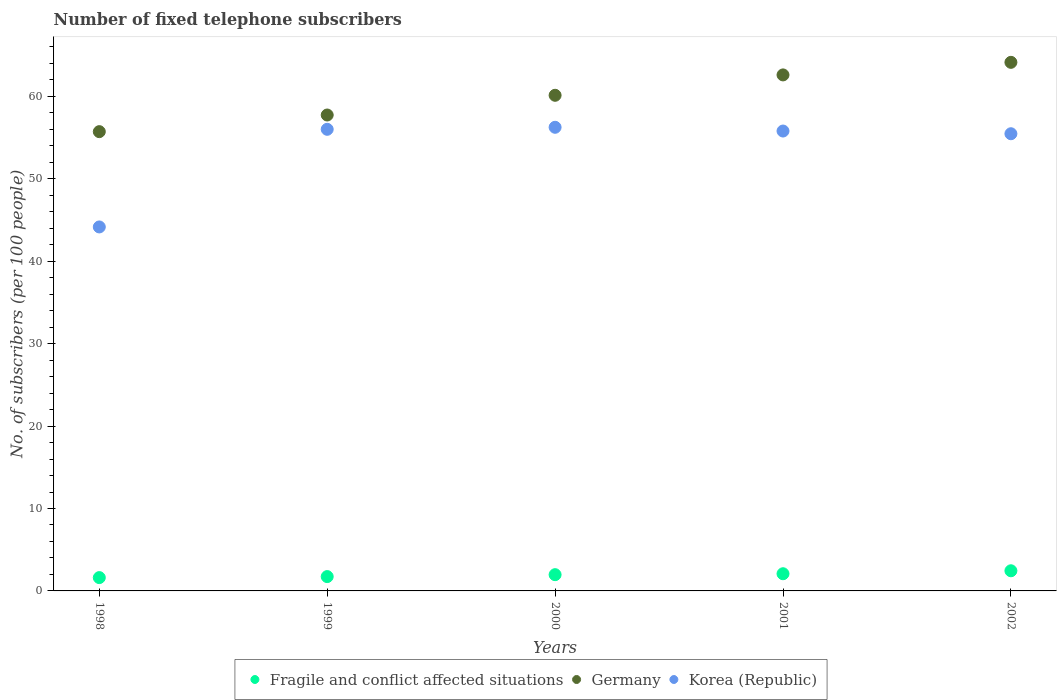How many different coloured dotlines are there?
Make the answer very short. 3. Is the number of dotlines equal to the number of legend labels?
Your answer should be very brief. Yes. What is the number of fixed telephone subscribers in Korea (Republic) in 2001?
Give a very brief answer. 55.8. Across all years, what is the maximum number of fixed telephone subscribers in Germany?
Your answer should be compact. 64.13. Across all years, what is the minimum number of fixed telephone subscribers in Korea (Republic)?
Ensure brevity in your answer.  44.16. What is the total number of fixed telephone subscribers in Fragile and conflict affected situations in the graph?
Your answer should be very brief. 9.86. What is the difference between the number of fixed telephone subscribers in Fragile and conflict affected situations in 2001 and that in 2002?
Keep it short and to the point. -0.36. What is the difference between the number of fixed telephone subscribers in Fragile and conflict affected situations in 1998 and the number of fixed telephone subscribers in Korea (Republic) in 2002?
Ensure brevity in your answer.  -53.85. What is the average number of fixed telephone subscribers in Korea (Republic) per year?
Your answer should be very brief. 53.54. In the year 2001, what is the difference between the number of fixed telephone subscribers in Germany and number of fixed telephone subscribers in Fragile and conflict affected situations?
Provide a succinct answer. 60.52. In how many years, is the number of fixed telephone subscribers in Korea (Republic) greater than 52?
Provide a short and direct response. 4. What is the ratio of the number of fixed telephone subscribers in Germany in 1999 to that in 2000?
Offer a very short reply. 0.96. What is the difference between the highest and the second highest number of fixed telephone subscribers in Fragile and conflict affected situations?
Your response must be concise. 0.36. What is the difference between the highest and the lowest number of fixed telephone subscribers in Fragile and conflict affected situations?
Your answer should be very brief. 0.83. Is the sum of the number of fixed telephone subscribers in Fragile and conflict affected situations in 1999 and 2000 greater than the maximum number of fixed telephone subscribers in Germany across all years?
Ensure brevity in your answer.  No. Does the number of fixed telephone subscribers in Korea (Republic) monotonically increase over the years?
Offer a terse response. No. Is the number of fixed telephone subscribers in Korea (Republic) strictly less than the number of fixed telephone subscribers in Germany over the years?
Give a very brief answer. Yes. What is the difference between two consecutive major ticks on the Y-axis?
Offer a very short reply. 10. Are the values on the major ticks of Y-axis written in scientific E-notation?
Give a very brief answer. No. Does the graph contain grids?
Give a very brief answer. No. Where does the legend appear in the graph?
Offer a terse response. Bottom center. How many legend labels are there?
Ensure brevity in your answer.  3. What is the title of the graph?
Your answer should be very brief. Number of fixed telephone subscribers. What is the label or title of the X-axis?
Give a very brief answer. Years. What is the label or title of the Y-axis?
Your response must be concise. No. of subscribers (per 100 people). What is the No. of subscribers (per 100 people) of Fragile and conflict affected situations in 1998?
Offer a very short reply. 1.62. What is the No. of subscribers (per 100 people) in Germany in 1998?
Offer a terse response. 55.72. What is the No. of subscribers (per 100 people) in Korea (Republic) in 1998?
Keep it short and to the point. 44.16. What is the No. of subscribers (per 100 people) in Fragile and conflict affected situations in 1999?
Your answer should be compact. 1.74. What is the No. of subscribers (per 100 people) in Germany in 1999?
Your answer should be compact. 57.74. What is the No. of subscribers (per 100 people) of Korea (Republic) in 1999?
Your response must be concise. 56.01. What is the No. of subscribers (per 100 people) in Fragile and conflict affected situations in 2000?
Provide a succinct answer. 1.97. What is the No. of subscribers (per 100 people) of Germany in 2000?
Give a very brief answer. 60.13. What is the No. of subscribers (per 100 people) of Korea (Republic) in 2000?
Your answer should be compact. 56.25. What is the No. of subscribers (per 100 people) of Fragile and conflict affected situations in 2001?
Your answer should be compact. 2.08. What is the No. of subscribers (per 100 people) in Germany in 2001?
Make the answer very short. 62.61. What is the No. of subscribers (per 100 people) in Korea (Republic) in 2001?
Provide a short and direct response. 55.8. What is the No. of subscribers (per 100 people) in Fragile and conflict affected situations in 2002?
Ensure brevity in your answer.  2.44. What is the No. of subscribers (per 100 people) in Germany in 2002?
Provide a succinct answer. 64.13. What is the No. of subscribers (per 100 people) of Korea (Republic) in 2002?
Make the answer very short. 55.47. Across all years, what is the maximum No. of subscribers (per 100 people) of Fragile and conflict affected situations?
Ensure brevity in your answer.  2.44. Across all years, what is the maximum No. of subscribers (per 100 people) of Germany?
Offer a terse response. 64.13. Across all years, what is the maximum No. of subscribers (per 100 people) in Korea (Republic)?
Offer a very short reply. 56.25. Across all years, what is the minimum No. of subscribers (per 100 people) in Fragile and conflict affected situations?
Give a very brief answer. 1.62. Across all years, what is the minimum No. of subscribers (per 100 people) of Germany?
Provide a succinct answer. 55.72. Across all years, what is the minimum No. of subscribers (per 100 people) in Korea (Republic)?
Offer a very short reply. 44.16. What is the total No. of subscribers (per 100 people) of Fragile and conflict affected situations in the graph?
Ensure brevity in your answer.  9.86. What is the total No. of subscribers (per 100 people) in Germany in the graph?
Make the answer very short. 300.34. What is the total No. of subscribers (per 100 people) in Korea (Republic) in the graph?
Your response must be concise. 267.69. What is the difference between the No. of subscribers (per 100 people) of Fragile and conflict affected situations in 1998 and that in 1999?
Your answer should be very brief. -0.12. What is the difference between the No. of subscribers (per 100 people) of Germany in 1998 and that in 1999?
Your answer should be very brief. -2.02. What is the difference between the No. of subscribers (per 100 people) of Korea (Republic) in 1998 and that in 1999?
Your response must be concise. -11.85. What is the difference between the No. of subscribers (per 100 people) in Fragile and conflict affected situations in 1998 and that in 2000?
Provide a succinct answer. -0.36. What is the difference between the No. of subscribers (per 100 people) in Germany in 1998 and that in 2000?
Make the answer very short. -4.41. What is the difference between the No. of subscribers (per 100 people) of Korea (Republic) in 1998 and that in 2000?
Keep it short and to the point. -12.09. What is the difference between the No. of subscribers (per 100 people) of Fragile and conflict affected situations in 1998 and that in 2001?
Your answer should be compact. -0.47. What is the difference between the No. of subscribers (per 100 people) in Germany in 1998 and that in 2001?
Provide a succinct answer. -6.88. What is the difference between the No. of subscribers (per 100 people) of Korea (Republic) in 1998 and that in 2001?
Provide a short and direct response. -11.64. What is the difference between the No. of subscribers (per 100 people) of Fragile and conflict affected situations in 1998 and that in 2002?
Make the answer very short. -0.83. What is the difference between the No. of subscribers (per 100 people) in Germany in 1998 and that in 2002?
Give a very brief answer. -8.41. What is the difference between the No. of subscribers (per 100 people) in Korea (Republic) in 1998 and that in 2002?
Provide a succinct answer. -11.31. What is the difference between the No. of subscribers (per 100 people) in Fragile and conflict affected situations in 1999 and that in 2000?
Your answer should be very brief. -0.23. What is the difference between the No. of subscribers (per 100 people) in Germany in 1999 and that in 2000?
Provide a succinct answer. -2.39. What is the difference between the No. of subscribers (per 100 people) in Korea (Republic) in 1999 and that in 2000?
Make the answer very short. -0.24. What is the difference between the No. of subscribers (per 100 people) in Fragile and conflict affected situations in 1999 and that in 2001?
Your answer should be compact. -0.35. What is the difference between the No. of subscribers (per 100 people) in Germany in 1999 and that in 2001?
Keep it short and to the point. -4.87. What is the difference between the No. of subscribers (per 100 people) in Korea (Republic) in 1999 and that in 2001?
Your response must be concise. 0.21. What is the difference between the No. of subscribers (per 100 people) of Fragile and conflict affected situations in 1999 and that in 2002?
Provide a succinct answer. -0.71. What is the difference between the No. of subscribers (per 100 people) in Germany in 1999 and that in 2002?
Provide a short and direct response. -6.39. What is the difference between the No. of subscribers (per 100 people) of Korea (Republic) in 1999 and that in 2002?
Your answer should be compact. 0.54. What is the difference between the No. of subscribers (per 100 people) in Fragile and conflict affected situations in 2000 and that in 2001?
Provide a short and direct response. -0.11. What is the difference between the No. of subscribers (per 100 people) in Germany in 2000 and that in 2001?
Your response must be concise. -2.47. What is the difference between the No. of subscribers (per 100 people) in Korea (Republic) in 2000 and that in 2001?
Make the answer very short. 0.45. What is the difference between the No. of subscribers (per 100 people) in Fragile and conflict affected situations in 2000 and that in 2002?
Ensure brevity in your answer.  -0.47. What is the difference between the No. of subscribers (per 100 people) of Germany in 2000 and that in 2002?
Provide a succinct answer. -4. What is the difference between the No. of subscribers (per 100 people) in Korea (Republic) in 2000 and that in 2002?
Your response must be concise. 0.78. What is the difference between the No. of subscribers (per 100 people) of Fragile and conflict affected situations in 2001 and that in 2002?
Your answer should be very brief. -0.36. What is the difference between the No. of subscribers (per 100 people) of Germany in 2001 and that in 2002?
Your answer should be compact. -1.53. What is the difference between the No. of subscribers (per 100 people) of Korea (Republic) in 2001 and that in 2002?
Provide a short and direct response. 0.33. What is the difference between the No. of subscribers (per 100 people) of Fragile and conflict affected situations in 1998 and the No. of subscribers (per 100 people) of Germany in 1999?
Ensure brevity in your answer.  -56.13. What is the difference between the No. of subscribers (per 100 people) in Fragile and conflict affected situations in 1998 and the No. of subscribers (per 100 people) in Korea (Republic) in 1999?
Your response must be concise. -54.39. What is the difference between the No. of subscribers (per 100 people) in Germany in 1998 and the No. of subscribers (per 100 people) in Korea (Republic) in 1999?
Give a very brief answer. -0.28. What is the difference between the No. of subscribers (per 100 people) in Fragile and conflict affected situations in 1998 and the No. of subscribers (per 100 people) in Germany in 2000?
Make the answer very short. -58.52. What is the difference between the No. of subscribers (per 100 people) in Fragile and conflict affected situations in 1998 and the No. of subscribers (per 100 people) in Korea (Republic) in 2000?
Your answer should be compact. -54.64. What is the difference between the No. of subscribers (per 100 people) of Germany in 1998 and the No. of subscribers (per 100 people) of Korea (Republic) in 2000?
Keep it short and to the point. -0.53. What is the difference between the No. of subscribers (per 100 people) of Fragile and conflict affected situations in 1998 and the No. of subscribers (per 100 people) of Germany in 2001?
Give a very brief answer. -60.99. What is the difference between the No. of subscribers (per 100 people) of Fragile and conflict affected situations in 1998 and the No. of subscribers (per 100 people) of Korea (Republic) in 2001?
Offer a very short reply. -54.18. What is the difference between the No. of subscribers (per 100 people) of Germany in 1998 and the No. of subscribers (per 100 people) of Korea (Republic) in 2001?
Offer a very short reply. -0.07. What is the difference between the No. of subscribers (per 100 people) in Fragile and conflict affected situations in 1998 and the No. of subscribers (per 100 people) in Germany in 2002?
Your answer should be compact. -62.52. What is the difference between the No. of subscribers (per 100 people) of Fragile and conflict affected situations in 1998 and the No. of subscribers (per 100 people) of Korea (Republic) in 2002?
Your response must be concise. -53.85. What is the difference between the No. of subscribers (per 100 people) in Germany in 1998 and the No. of subscribers (per 100 people) in Korea (Republic) in 2002?
Your answer should be compact. 0.25. What is the difference between the No. of subscribers (per 100 people) in Fragile and conflict affected situations in 1999 and the No. of subscribers (per 100 people) in Germany in 2000?
Ensure brevity in your answer.  -58.4. What is the difference between the No. of subscribers (per 100 people) in Fragile and conflict affected situations in 1999 and the No. of subscribers (per 100 people) in Korea (Republic) in 2000?
Your answer should be very brief. -54.51. What is the difference between the No. of subscribers (per 100 people) in Germany in 1999 and the No. of subscribers (per 100 people) in Korea (Republic) in 2000?
Keep it short and to the point. 1.49. What is the difference between the No. of subscribers (per 100 people) of Fragile and conflict affected situations in 1999 and the No. of subscribers (per 100 people) of Germany in 2001?
Offer a terse response. -60.87. What is the difference between the No. of subscribers (per 100 people) in Fragile and conflict affected situations in 1999 and the No. of subscribers (per 100 people) in Korea (Republic) in 2001?
Keep it short and to the point. -54.06. What is the difference between the No. of subscribers (per 100 people) of Germany in 1999 and the No. of subscribers (per 100 people) of Korea (Republic) in 2001?
Give a very brief answer. 1.94. What is the difference between the No. of subscribers (per 100 people) of Fragile and conflict affected situations in 1999 and the No. of subscribers (per 100 people) of Germany in 2002?
Make the answer very short. -62.39. What is the difference between the No. of subscribers (per 100 people) of Fragile and conflict affected situations in 1999 and the No. of subscribers (per 100 people) of Korea (Republic) in 2002?
Provide a short and direct response. -53.73. What is the difference between the No. of subscribers (per 100 people) in Germany in 1999 and the No. of subscribers (per 100 people) in Korea (Republic) in 2002?
Make the answer very short. 2.27. What is the difference between the No. of subscribers (per 100 people) of Fragile and conflict affected situations in 2000 and the No. of subscribers (per 100 people) of Germany in 2001?
Provide a short and direct response. -60.64. What is the difference between the No. of subscribers (per 100 people) of Fragile and conflict affected situations in 2000 and the No. of subscribers (per 100 people) of Korea (Republic) in 2001?
Ensure brevity in your answer.  -53.83. What is the difference between the No. of subscribers (per 100 people) of Germany in 2000 and the No. of subscribers (per 100 people) of Korea (Republic) in 2001?
Provide a short and direct response. 4.34. What is the difference between the No. of subscribers (per 100 people) in Fragile and conflict affected situations in 2000 and the No. of subscribers (per 100 people) in Germany in 2002?
Your answer should be very brief. -62.16. What is the difference between the No. of subscribers (per 100 people) of Fragile and conflict affected situations in 2000 and the No. of subscribers (per 100 people) of Korea (Republic) in 2002?
Your response must be concise. -53.5. What is the difference between the No. of subscribers (per 100 people) in Germany in 2000 and the No. of subscribers (per 100 people) in Korea (Republic) in 2002?
Offer a terse response. 4.66. What is the difference between the No. of subscribers (per 100 people) of Fragile and conflict affected situations in 2001 and the No. of subscribers (per 100 people) of Germany in 2002?
Provide a succinct answer. -62.05. What is the difference between the No. of subscribers (per 100 people) of Fragile and conflict affected situations in 2001 and the No. of subscribers (per 100 people) of Korea (Republic) in 2002?
Offer a very short reply. -53.39. What is the difference between the No. of subscribers (per 100 people) of Germany in 2001 and the No. of subscribers (per 100 people) of Korea (Republic) in 2002?
Give a very brief answer. 7.14. What is the average No. of subscribers (per 100 people) of Fragile and conflict affected situations per year?
Your answer should be compact. 1.97. What is the average No. of subscribers (per 100 people) in Germany per year?
Your answer should be very brief. 60.07. What is the average No. of subscribers (per 100 people) in Korea (Republic) per year?
Your answer should be very brief. 53.54. In the year 1998, what is the difference between the No. of subscribers (per 100 people) in Fragile and conflict affected situations and No. of subscribers (per 100 people) in Germany?
Provide a short and direct response. -54.11. In the year 1998, what is the difference between the No. of subscribers (per 100 people) of Fragile and conflict affected situations and No. of subscribers (per 100 people) of Korea (Republic)?
Keep it short and to the point. -42.55. In the year 1998, what is the difference between the No. of subscribers (per 100 people) of Germany and No. of subscribers (per 100 people) of Korea (Republic)?
Ensure brevity in your answer.  11.56. In the year 1999, what is the difference between the No. of subscribers (per 100 people) in Fragile and conflict affected situations and No. of subscribers (per 100 people) in Germany?
Offer a very short reply. -56. In the year 1999, what is the difference between the No. of subscribers (per 100 people) in Fragile and conflict affected situations and No. of subscribers (per 100 people) in Korea (Republic)?
Your response must be concise. -54.27. In the year 1999, what is the difference between the No. of subscribers (per 100 people) in Germany and No. of subscribers (per 100 people) in Korea (Republic)?
Ensure brevity in your answer.  1.74. In the year 2000, what is the difference between the No. of subscribers (per 100 people) in Fragile and conflict affected situations and No. of subscribers (per 100 people) in Germany?
Keep it short and to the point. -58.16. In the year 2000, what is the difference between the No. of subscribers (per 100 people) in Fragile and conflict affected situations and No. of subscribers (per 100 people) in Korea (Republic)?
Your response must be concise. -54.28. In the year 2000, what is the difference between the No. of subscribers (per 100 people) in Germany and No. of subscribers (per 100 people) in Korea (Republic)?
Provide a short and direct response. 3.88. In the year 2001, what is the difference between the No. of subscribers (per 100 people) of Fragile and conflict affected situations and No. of subscribers (per 100 people) of Germany?
Your answer should be very brief. -60.52. In the year 2001, what is the difference between the No. of subscribers (per 100 people) of Fragile and conflict affected situations and No. of subscribers (per 100 people) of Korea (Republic)?
Make the answer very short. -53.71. In the year 2001, what is the difference between the No. of subscribers (per 100 people) of Germany and No. of subscribers (per 100 people) of Korea (Republic)?
Offer a terse response. 6.81. In the year 2002, what is the difference between the No. of subscribers (per 100 people) in Fragile and conflict affected situations and No. of subscribers (per 100 people) in Germany?
Provide a succinct answer. -61.69. In the year 2002, what is the difference between the No. of subscribers (per 100 people) of Fragile and conflict affected situations and No. of subscribers (per 100 people) of Korea (Republic)?
Your answer should be compact. -53.03. In the year 2002, what is the difference between the No. of subscribers (per 100 people) in Germany and No. of subscribers (per 100 people) in Korea (Republic)?
Make the answer very short. 8.66. What is the ratio of the No. of subscribers (per 100 people) of Fragile and conflict affected situations in 1998 to that in 1999?
Provide a succinct answer. 0.93. What is the ratio of the No. of subscribers (per 100 people) of Korea (Republic) in 1998 to that in 1999?
Keep it short and to the point. 0.79. What is the ratio of the No. of subscribers (per 100 people) of Fragile and conflict affected situations in 1998 to that in 2000?
Offer a very short reply. 0.82. What is the ratio of the No. of subscribers (per 100 people) in Germany in 1998 to that in 2000?
Provide a short and direct response. 0.93. What is the ratio of the No. of subscribers (per 100 people) of Korea (Republic) in 1998 to that in 2000?
Keep it short and to the point. 0.79. What is the ratio of the No. of subscribers (per 100 people) of Fragile and conflict affected situations in 1998 to that in 2001?
Your response must be concise. 0.78. What is the ratio of the No. of subscribers (per 100 people) in Germany in 1998 to that in 2001?
Provide a short and direct response. 0.89. What is the ratio of the No. of subscribers (per 100 people) of Korea (Republic) in 1998 to that in 2001?
Offer a terse response. 0.79. What is the ratio of the No. of subscribers (per 100 people) of Fragile and conflict affected situations in 1998 to that in 2002?
Provide a succinct answer. 0.66. What is the ratio of the No. of subscribers (per 100 people) of Germany in 1998 to that in 2002?
Your response must be concise. 0.87. What is the ratio of the No. of subscribers (per 100 people) in Korea (Republic) in 1998 to that in 2002?
Your response must be concise. 0.8. What is the ratio of the No. of subscribers (per 100 people) of Fragile and conflict affected situations in 1999 to that in 2000?
Your response must be concise. 0.88. What is the ratio of the No. of subscribers (per 100 people) in Germany in 1999 to that in 2000?
Offer a very short reply. 0.96. What is the ratio of the No. of subscribers (per 100 people) of Fragile and conflict affected situations in 1999 to that in 2001?
Your response must be concise. 0.83. What is the ratio of the No. of subscribers (per 100 people) in Germany in 1999 to that in 2001?
Ensure brevity in your answer.  0.92. What is the ratio of the No. of subscribers (per 100 people) of Korea (Republic) in 1999 to that in 2001?
Keep it short and to the point. 1. What is the ratio of the No. of subscribers (per 100 people) of Fragile and conflict affected situations in 1999 to that in 2002?
Offer a very short reply. 0.71. What is the ratio of the No. of subscribers (per 100 people) in Germany in 1999 to that in 2002?
Give a very brief answer. 0.9. What is the ratio of the No. of subscribers (per 100 people) in Korea (Republic) in 1999 to that in 2002?
Provide a short and direct response. 1.01. What is the ratio of the No. of subscribers (per 100 people) in Fragile and conflict affected situations in 2000 to that in 2001?
Provide a succinct answer. 0.95. What is the ratio of the No. of subscribers (per 100 people) in Germany in 2000 to that in 2001?
Provide a succinct answer. 0.96. What is the ratio of the No. of subscribers (per 100 people) of Fragile and conflict affected situations in 2000 to that in 2002?
Your answer should be very brief. 0.81. What is the ratio of the No. of subscribers (per 100 people) in Germany in 2000 to that in 2002?
Your response must be concise. 0.94. What is the ratio of the No. of subscribers (per 100 people) in Korea (Republic) in 2000 to that in 2002?
Ensure brevity in your answer.  1.01. What is the ratio of the No. of subscribers (per 100 people) of Fragile and conflict affected situations in 2001 to that in 2002?
Offer a very short reply. 0.85. What is the ratio of the No. of subscribers (per 100 people) in Germany in 2001 to that in 2002?
Provide a short and direct response. 0.98. What is the ratio of the No. of subscribers (per 100 people) in Korea (Republic) in 2001 to that in 2002?
Your answer should be compact. 1.01. What is the difference between the highest and the second highest No. of subscribers (per 100 people) in Fragile and conflict affected situations?
Ensure brevity in your answer.  0.36. What is the difference between the highest and the second highest No. of subscribers (per 100 people) of Germany?
Offer a terse response. 1.53. What is the difference between the highest and the second highest No. of subscribers (per 100 people) in Korea (Republic)?
Ensure brevity in your answer.  0.24. What is the difference between the highest and the lowest No. of subscribers (per 100 people) in Fragile and conflict affected situations?
Keep it short and to the point. 0.83. What is the difference between the highest and the lowest No. of subscribers (per 100 people) of Germany?
Keep it short and to the point. 8.41. What is the difference between the highest and the lowest No. of subscribers (per 100 people) of Korea (Republic)?
Provide a short and direct response. 12.09. 